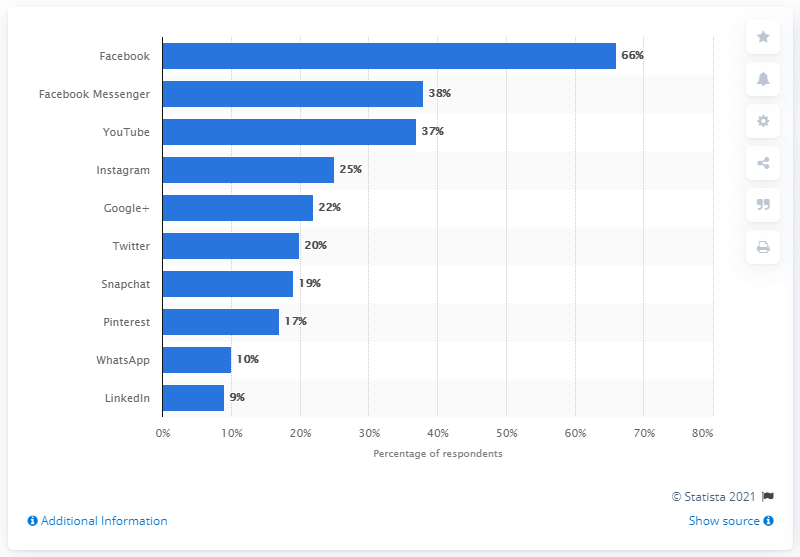Indicate a few pertinent items in this graphic. According to data, Facebook had the highest daily user engagement rate among all social networks. 